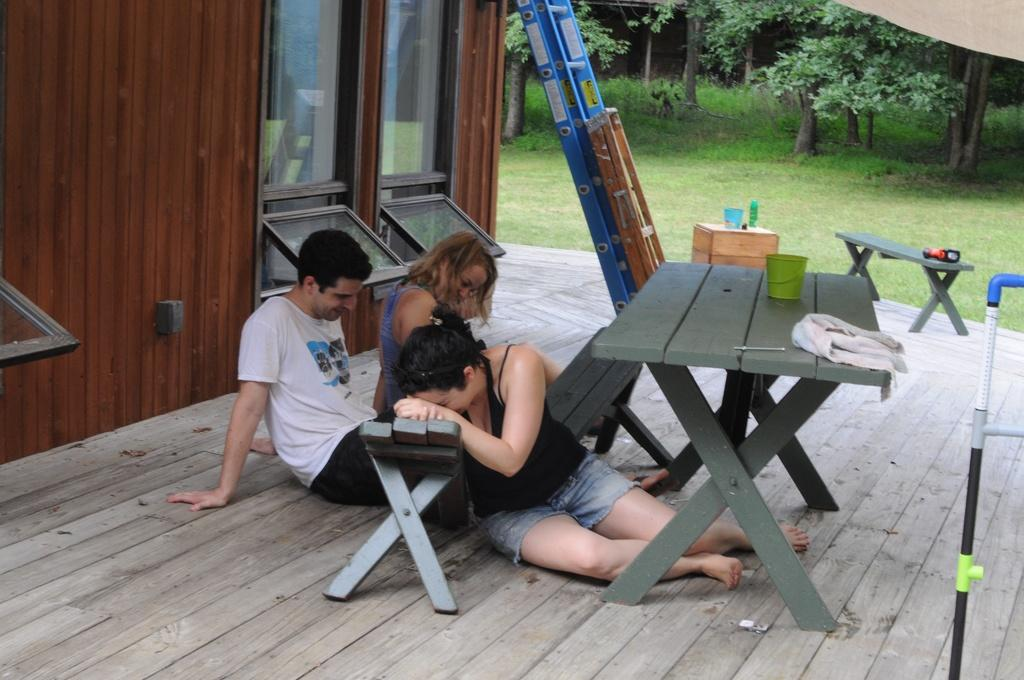How many people are in the image? There are three people in the image: one man and two women. What are the people doing in the image? The people are sitting on the floor. What is in front of the people? There is a table in front of the people. What can be seen on the table? There is a glass and a cloth on the table. What can be seen in the background of the image? There is grass and trees visible in the background. What country is the man from in the image? The image does not provide any information about the man's country of origin, so it cannot be determined. 